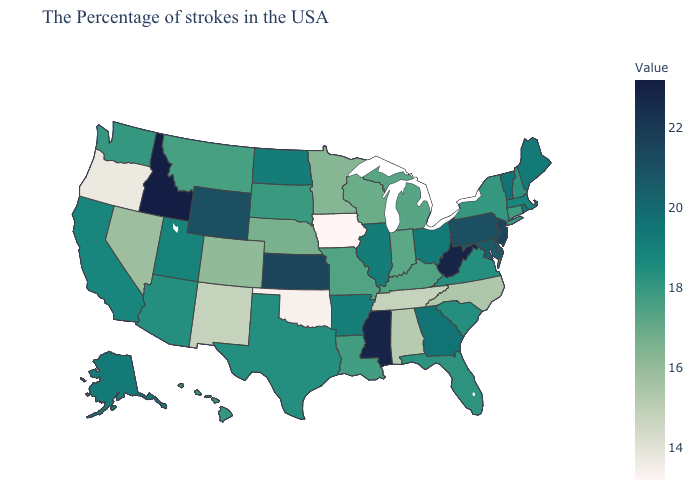Among the states that border Virginia , does West Virginia have the highest value?
Keep it brief. Yes. Does Oklahoma have the lowest value in the South?
Quick response, please. Yes. Among the states that border Kentucky , which have the lowest value?
Give a very brief answer. Tennessee. 